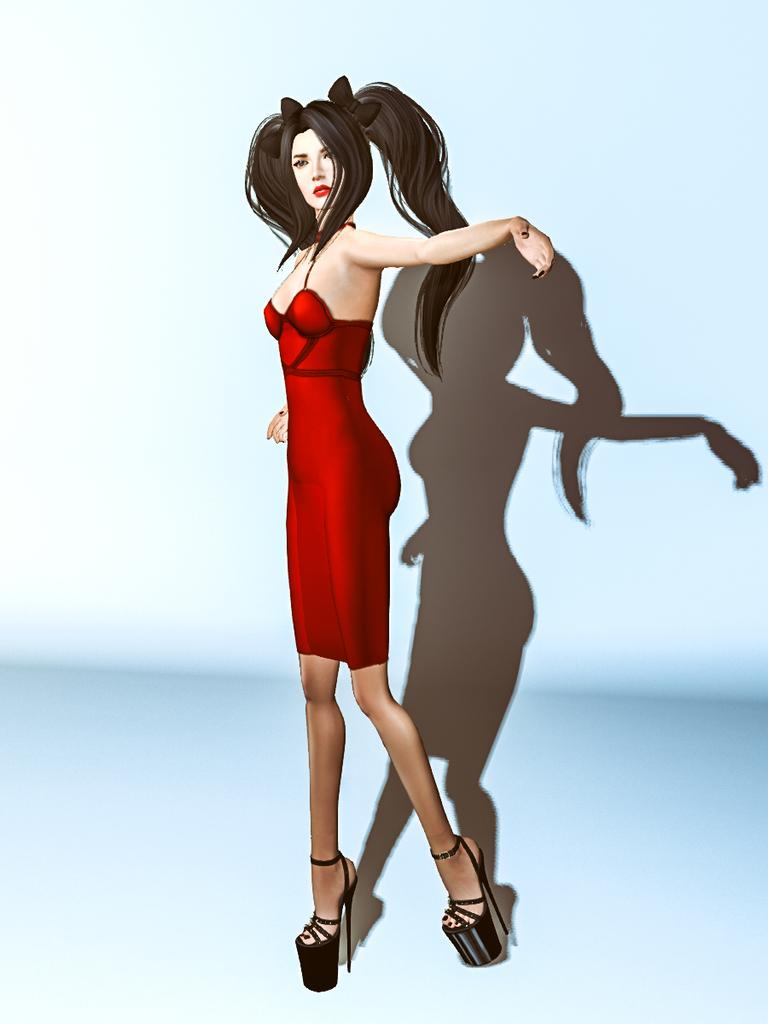What type of image is depicted in the picture? There is a cartoon picture of a woman in the image. What type of metal is used to create the skate in the image? There is no skate present in the image; it features a cartoon picture of a woman. 